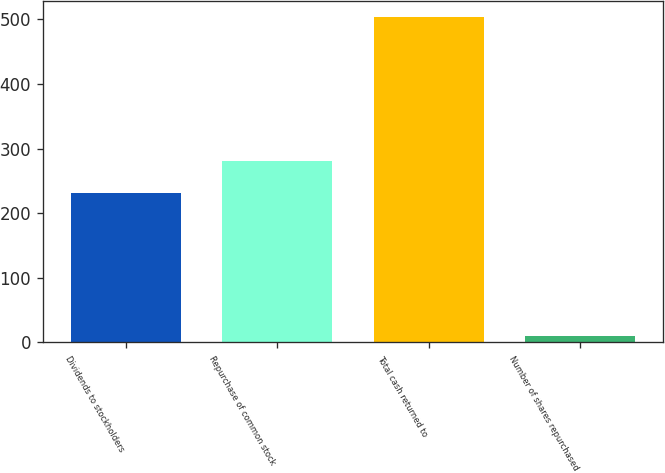<chart> <loc_0><loc_0><loc_500><loc_500><bar_chart><fcel>Dividends to stockholders<fcel>Repurchase of common stock<fcel>Total cash returned to<fcel>Number of shares repurchased<nl><fcel>231.3<fcel>280.65<fcel>504<fcel>10.5<nl></chart> 